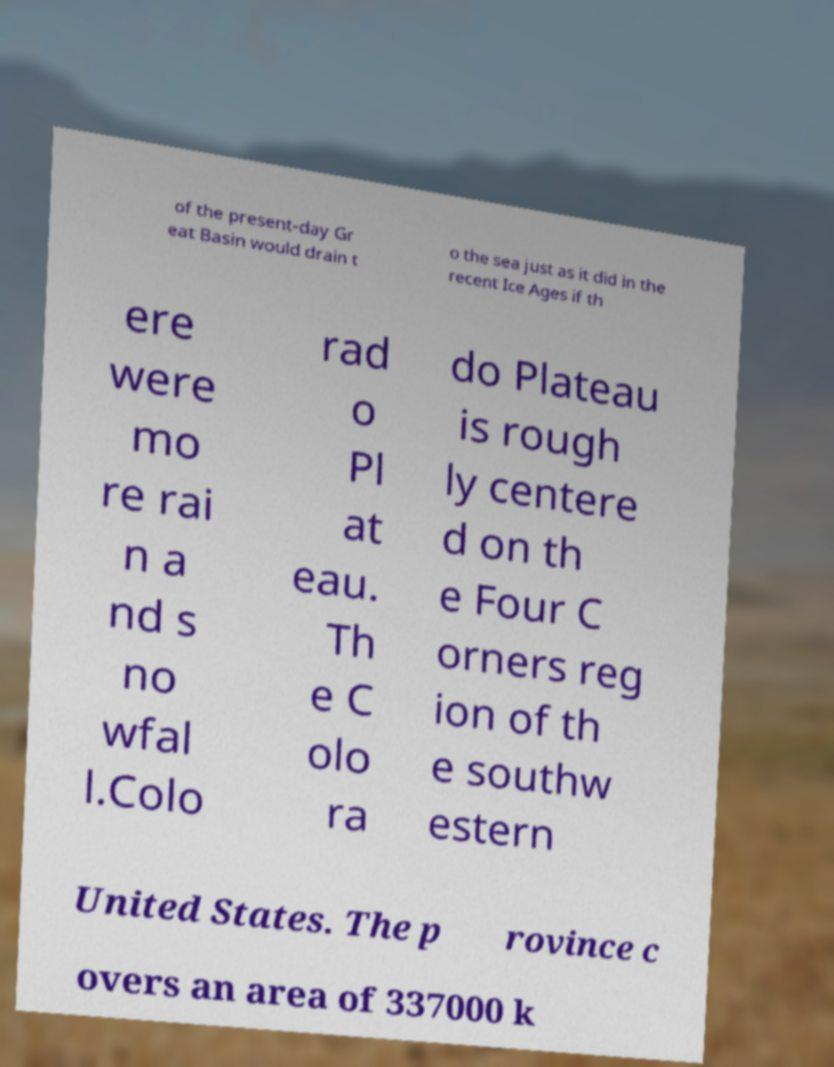What messages or text are displayed in this image? I need them in a readable, typed format. of the present-day Gr eat Basin would drain t o the sea just as it did in the recent Ice Ages if th ere were mo re rai n a nd s no wfal l.Colo rad o Pl at eau. Th e C olo ra do Plateau is rough ly centere d on th e Four C orners reg ion of th e southw estern United States. The p rovince c overs an area of 337000 k 